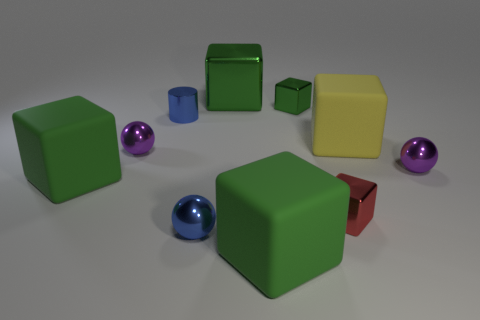Subtract all green blocks. How many were subtracted if there are1green blocks left? 3 Subtract all blue metallic spheres. How many spheres are left? 2 Subtract all purple cylinders. How many green cubes are left? 4 Subtract 1 spheres. How many spheres are left? 2 Subtract all purple balls. How many balls are left? 1 Subtract all gray cubes. Subtract all blue spheres. How many cubes are left? 6 Add 2 small green shiny cubes. How many small green shiny cubes are left? 3 Add 4 tiny objects. How many tiny objects exist? 10 Subtract 0 gray cylinders. How many objects are left? 10 Subtract all cylinders. How many objects are left? 9 